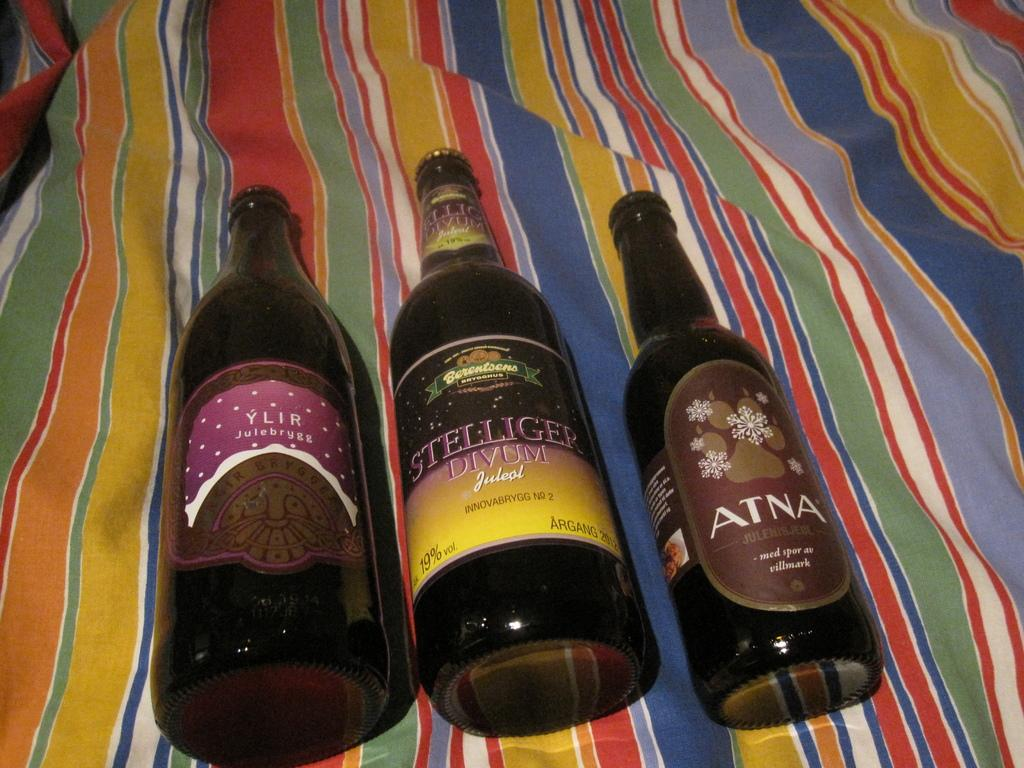Provide a one-sentence caption for the provided image. An opened bottle of Atna lies on a colorful cloth with two other bottles. 